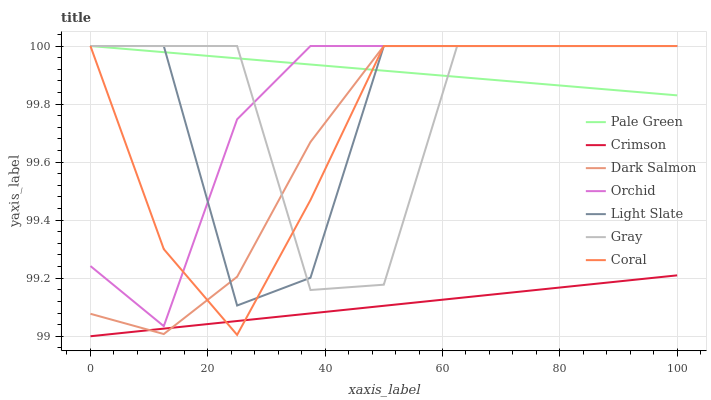Does Crimson have the minimum area under the curve?
Answer yes or no. Yes. Does Pale Green have the maximum area under the curve?
Answer yes or no. Yes. Does Light Slate have the minimum area under the curve?
Answer yes or no. No. Does Light Slate have the maximum area under the curve?
Answer yes or no. No. Is Pale Green the smoothest?
Answer yes or no. Yes. Is Light Slate the roughest?
Answer yes or no. Yes. Is Coral the smoothest?
Answer yes or no. No. Is Coral the roughest?
Answer yes or no. No. Does Light Slate have the lowest value?
Answer yes or no. No. Does Orchid have the highest value?
Answer yes or no. Yes. Does Crimson have the highest value?
Answer yes or no. No. Is Crimson less than Orchid?
Answer yes or no. Yes. Is Orchid greater than Crimson?
Answer yes or no. Yes. Does Pale Green intersect Orchid?
Answer yes or no. Yes. Is Pale Green less than Orchid?
Answer yes or no. No. Is Pale Green greater than Orchid?
Answer yes or no. No. Does Crimson intersect Orchid?
Answer yes or no. No. 